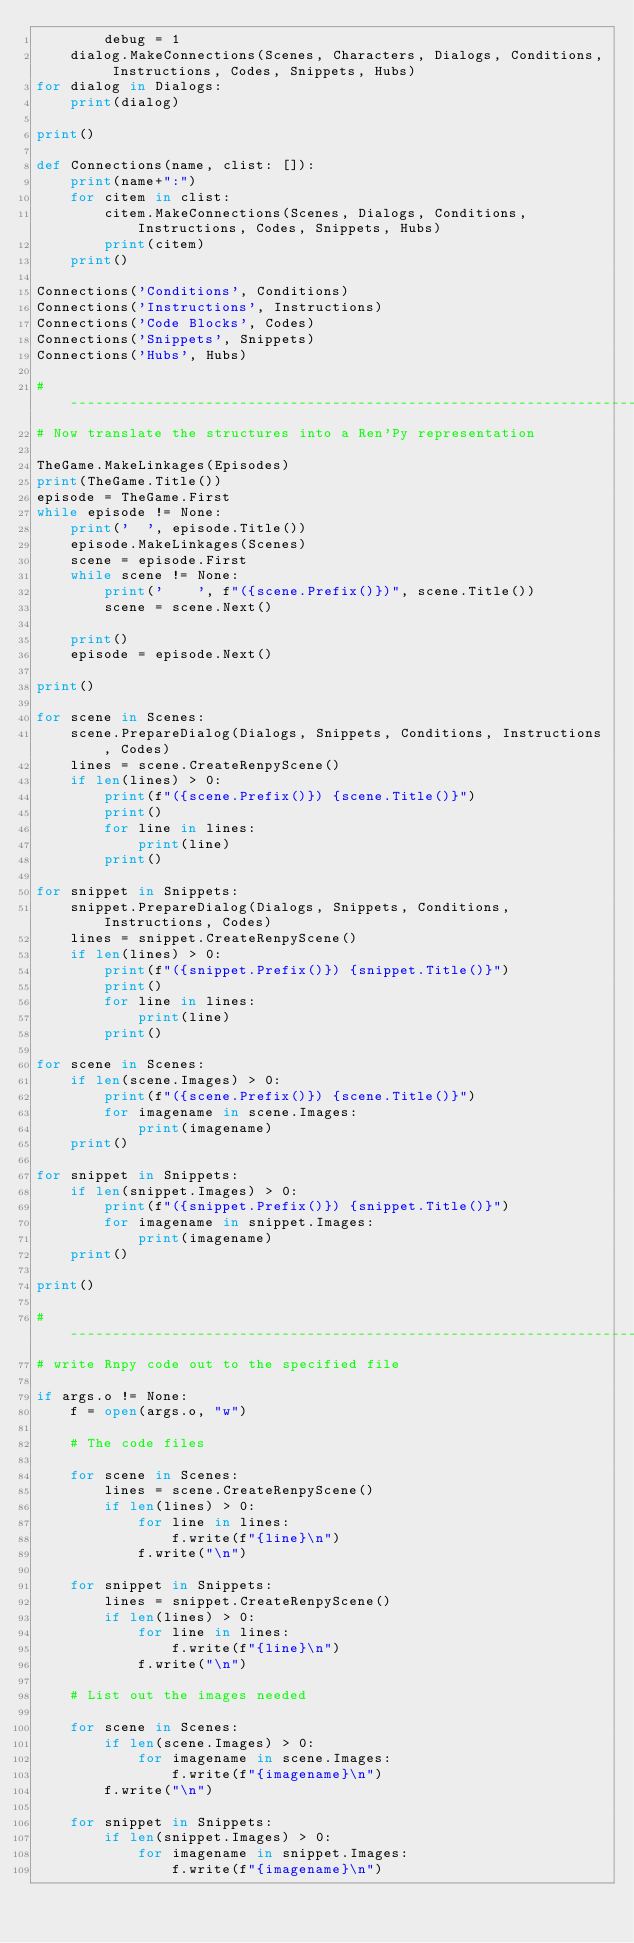Convert code to text. <code><loc_0><loc_0><loc_500><loc_500><_Python_>        debug = 1
    dialog.MakeConnections(Scenes, Characters, Dialogs, Conditions, Instructions, Codes, Snippets, Hubs)
for dialog in Dialogs:
    print(dialog)

print()

def Connections(name, clist: []):
    print(name+":")
    for citem in clist:
        citem.MakeConnections(Scenes, Dialogs, Conditions, Instructions, Codes, Snippets, Hubs)
        print(citem)
    print()

Connections('Conditions', Conditions)
Connections('Instructions', Instructions)
Connections('Code Blocks', Codes)
Connections('Snippets', Snippets)
Connections('Hubs', Hubs)

#-------------------------------------------------------------------------------
# Now translate the structures into a Ren'Py representation

TheGame.MakeLinkages(Episodes)
print(TheGame.Title())
episode = TheGame.First
while episode != None:
    print('  ', episode.Title())
    episode.MakeLinkages(Scenes)
    scene = episode.First
    while scene != None:
        print('    ', f"({scene.Prefix()})", scene.Title())
        scene = scene.Next()

    print()
    episode = episode.Next()

print()

for scene in Scenes:
    scene.PrepareDialog(Dialogs, Snippets, Conditions, Instructions, Codes)
    lines = scene.CreateRenpyScene()
    if len(lines) > 0:
        print(f"({scene.Prefix()}) {scene.Title()}")
        print()
        for line in lines:
            print(line)
        print()

for snippet in Snippets:
    snippet.PrepareDialog(Dialogs, Snippets, Conditions, Instructions, Codes)
    lines = snippet.CreateRenpyScene()
    if len(lines) > 0:
        print(f"({snippet.Prefix()}) {snippet.Title()}")
        print()
        for line in lines:
            print(line)
        print()

for scene in Scenes:
    if len(scene.Images) > 0:
        print(f"({scene.Prefix()}) {scene.Title()}")
        for imagename in scene.Images:
            print(imagename)
    print()

for snippet in Snippets:
    if len(snippet.Images) > 0:
        print(f"({snippet.Prefix()}) {snippet.Title()}")
        for imagename in snippet.Images:
            print(imagename)
    print()

print()

#-------------------------------------------------------------------------------
# write Rnpy code out to the specified file

if args.o != None:
    f = open(args.o, "w")

    # The code files

    for scene in Scenes:
        lines = scene.CreateRenpyScene()
        if len(lines) > 0:
            for line in lines:
                f.write(f"{line}\n")
            f.write("\n")

    for snippet in Snippets:
        lines = snippet.CreateRenpyScene()
        if len(lines) > 0:
            for line in lines:
                f.write(f"{line}\n")
            f.write("\n")

    # List out the images needed

    for scene in Scenes:
        if len(scene.Images) > 0:
            for imagename in scene.Images:
                f.write(f"{imagename}\n")
        f.write("\n")

    for snippet in Snippets:
        if len(snippet.Images) > 0:
            for imagename in snippet.Images:
                f.write(f"{imagename}\n")</code> 